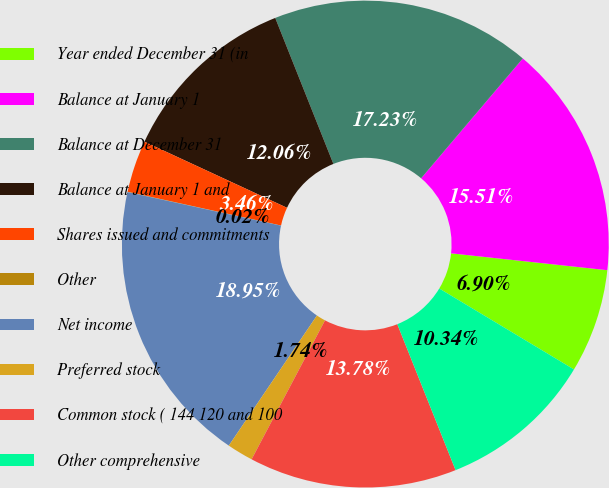Convert chart to OTSL. <chart><loc_0><loc_0><loc_500><loc_500><pie_chart><fcel>Year ended December 31 (in<fcel>Balance at January 1<fcel>Balance at December 31<fcel>Balance at January 1 and<fcel>Shares issued and commitments<fcel>Other<fcel>Net income<fcel>Preferred stock<fcel>Common stock ( 144 120 and 100<fcel>Other comprehensive<nl><fcel>6.9%<fcel>15.51%<fcel>17.23%<fcel>12.06%<fcel>3.46%<fcel>0.02%<fcel>18.95%<fcel>1.74%<fcel>13.78%<fcel>10.34%<nl></chart> 